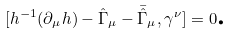Convert formula to latex. <formula><loc_0><loc_0><loc_500><loc_500>[ h ^ { - 1 } ( \partial _ { \mu } h ) - \hat { \Gamma } _ { \mu } - \bar { \hat { \Gamma } } _ { \mu } , \gamma ^ { \nu } ] = 0 \text {.}</formula> 